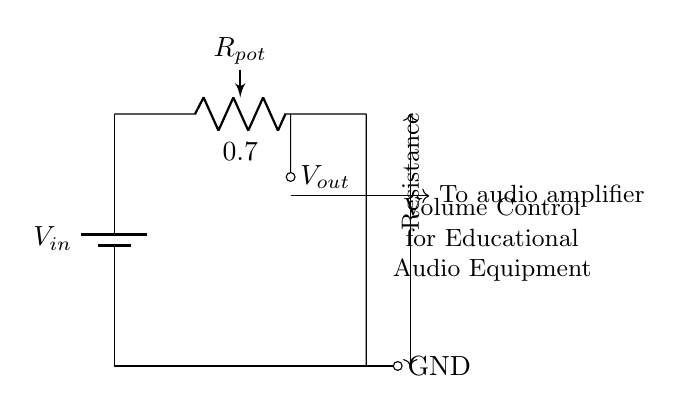What is the input voltage of the circuit? The input voltage is represented by the symbol V in the circuit diagram. Since only V is labeled without a specific numerical value, it stands as V in a general sense. Typically, this could represent various voltage levels in educational equipment.
Answer: V What is the purpose of the potentiometer in this circuit? The potentiometer in the circuit acts as a variable resistor that can adjust the output voltage. In this context, it serves to control the volume by allowing the user to set the desired output level to the audio amplifier.
Answer: Volume control How many terminals does the potentiometer have? The potentiometer depicted in the circuit typically has three terminals: one connected to the input voltage, one to ground, and the third as the output voltage tap. The connection to the audio amplifier utilizes the adjustable nature of the potentiometer.
Answer: Three What is the relationship between output voltage and resistance? The output voltage is a fraction of the input voltage determined by the relative resistances of the potentiometer's wiper position. As the wiper moves, it changes the effective resistance affecting the output voltage according to the voltage divider rule.
Answer: Voltage divider rule What connects the output voltage to the audio amplifier? The output voltage is connected to the audio amplifier through a direct short connection from the potentiometer's wiper position. This design allows the adjusted voltage to feed directly into the audio equipment for sound modulation.
Answer: Short connection 